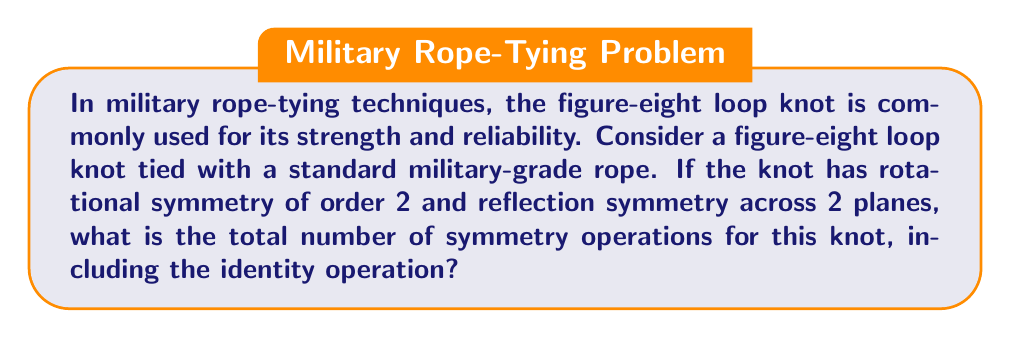Help me with this question. Let's approach this step-by-step:

1) First, let's identify the symmetry operations:
   - Identity operation (always present): 1
   - Rotational symmetry of order 2: 1 (180° rotation)
   - Reflection symmetry across 2 planes: 2

2) To calculate the total number of symmetry operations, we sum these up:
   $$\text{Total} = \text{Identity} + \text{Rotations} + \text{Reflections}$$
   $$\text{Total} = 1 + 1 + 2 = 4$$

3) We can verify this result using the orbit-stabilizer theorem from group theory. For a figure-eight knot:
   - The symmetry group is isomorphic to $D_2$, the dihedral group of order 4.
   - $D_2$ has 4 elements: $\{e, r, s, rs\}$ where $e$ is the identity, $r$ is the rotation, and $s$ and $rs$ are the two reflections.

4) This aligns with our manual calculation, confirming that the total number of symmetry operations is indeed 4.
Answer: 4 